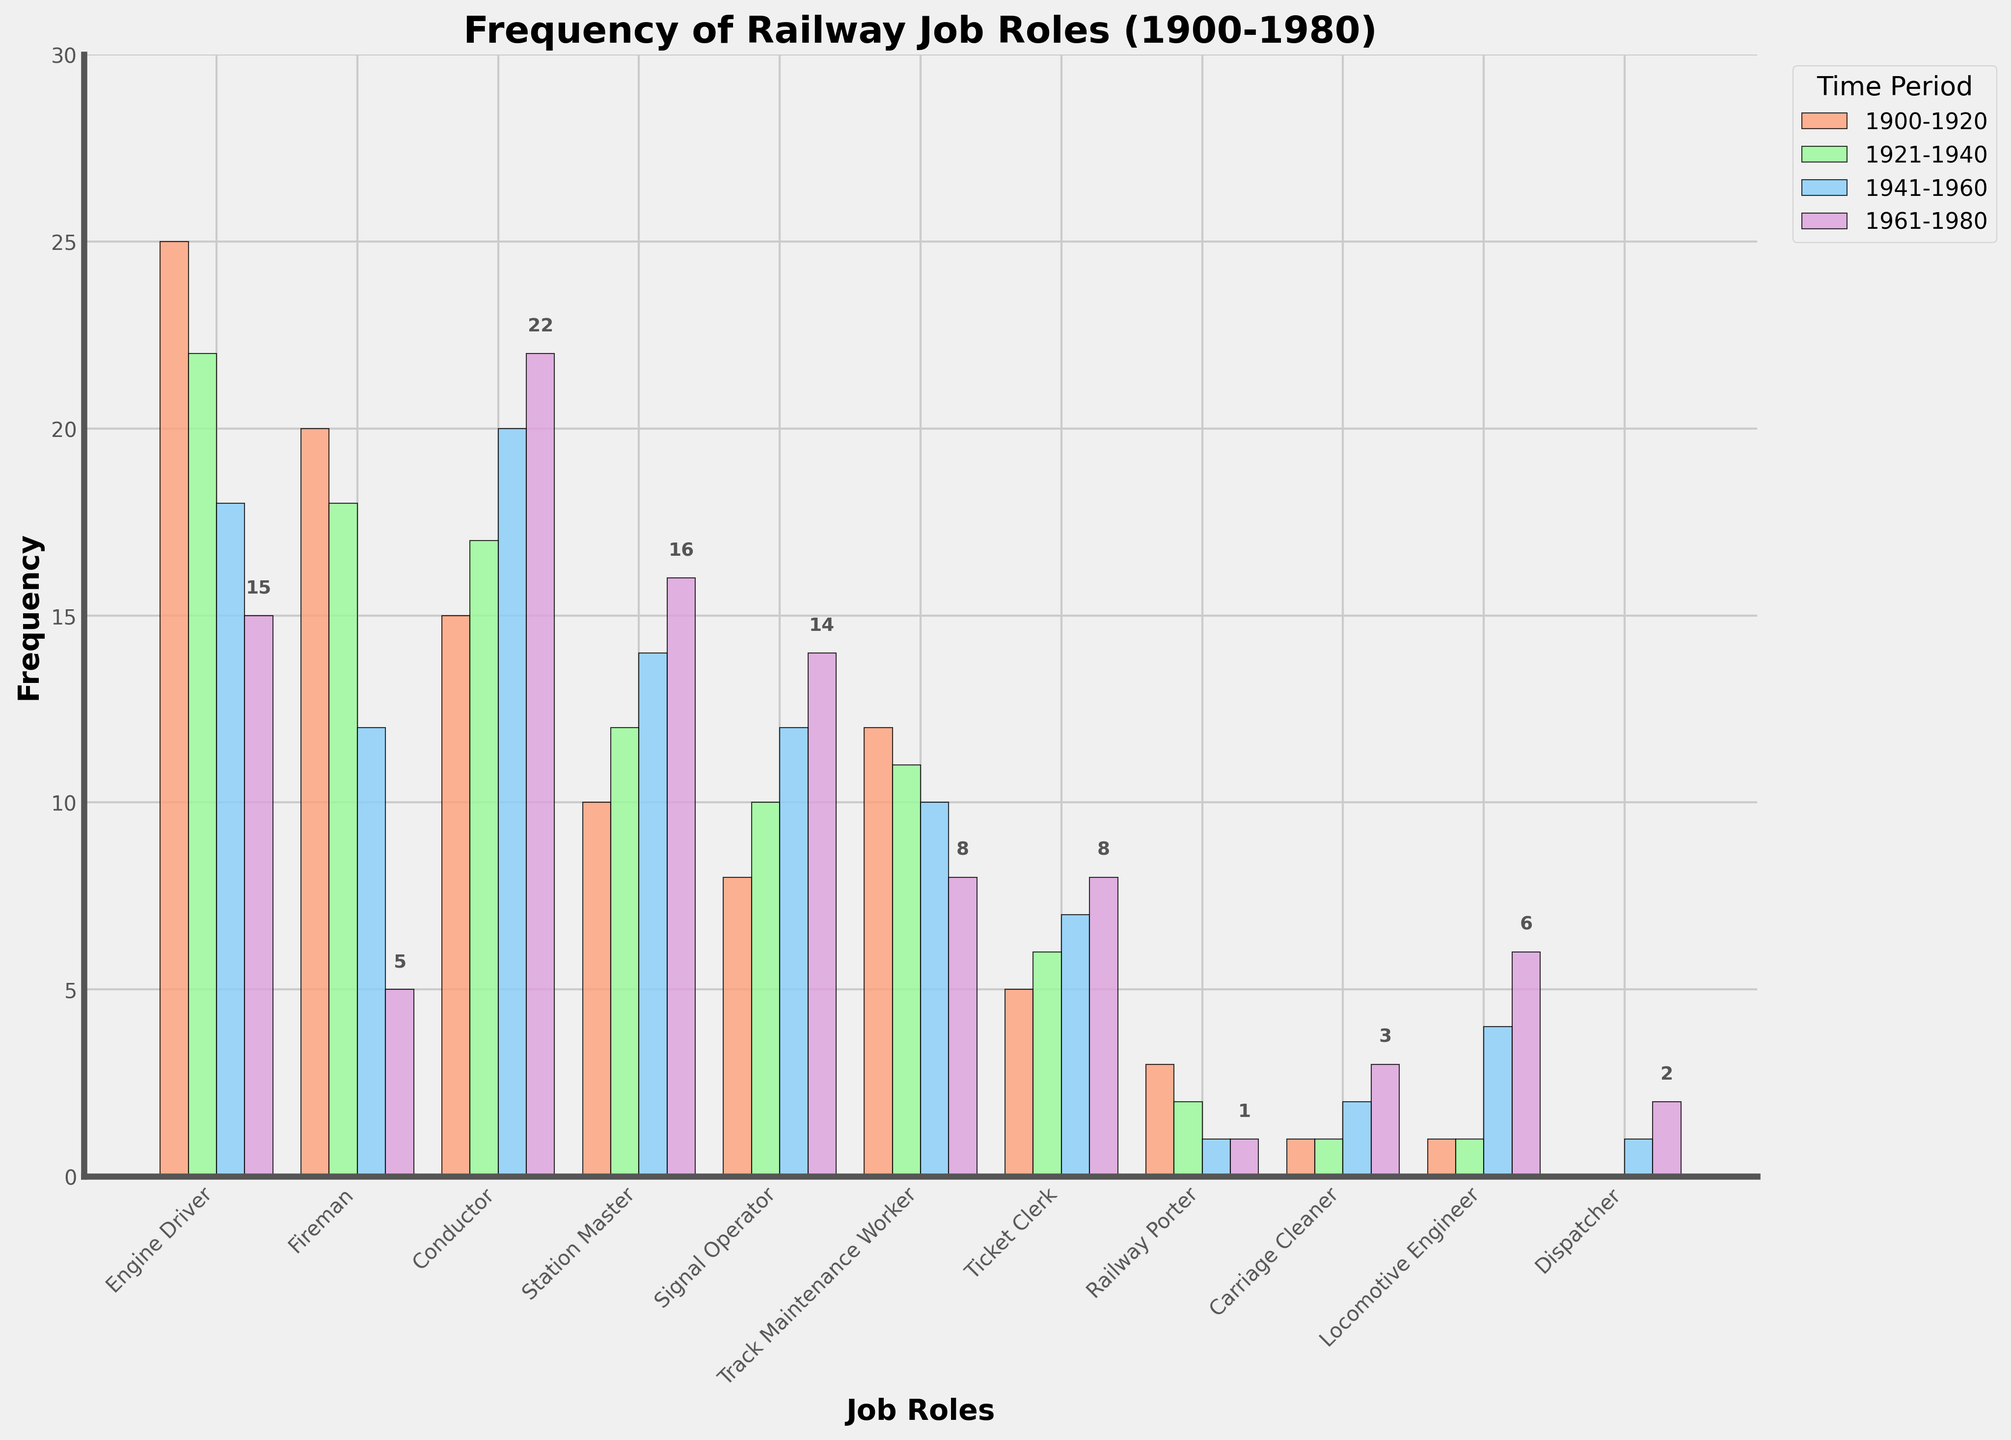What was the most common job role in the period 1900-1920? The job role with the highest frequency in the period 1900-1920 is identified by locating the tallest bar in the corresponding section of the bar chart. The 'Engine Driver' role has the tallest bar.
Answer: Engine Driver Which job role had the greatest increase in frequency from 1941-1960 to 1961-1980? To determine the job role with the greatest increase in frequency, compare the height of the bars between the periods 1941-1960 and 1961-1980 for each job role. The 'Conductor' increased from 20 to 22, which is the largest increase of 2.
Answer: Conductor How much did the frequency of the 'Fireman' role decrease from 1900-1920 to 1961-1980? Calculate the difference in frequency of the 'Fireman' role between 1900-1920 and 1961-1980 by subtracting the frequency in 1961-1980 from the frequency in 1900-1920 (20 - 5).
Answer: 15 Compare the frequency of the 'Station Master' and 'Signal Operator' roles in the period 1961-1980. Which one was more common? Compare the height of the bars for 'Station Master' (16) and 'Signal Operator' (14) in the period 1961-1980. 'Station Master' has a higher frequency.
Answer: Station Master What is the total frequency of the 'Ticket Clerk' role over all periods? Sum the frequencies of the 'Ticket Clerk' role across all periods: 5 (1900-1920) + 6 (1921-1940) + 7 (1941-1960) + 8 (1961-1980).
Answer: 26 In which period did the 'Locomotive Engineer' role experience its first increase in frequency? Identify the period when the 'Locomotive Engineer' first experienced a noticeable increase by analyzing the heights of the bars in sequence. The first increase is from 1941-1960 with a frequency of 4 compared to previous periods.
Answer: 1941-1960 How does the frequency of the 'Carriage Cleaner' role in 1961-1980 compare to its frequency in 1900-1920? Compare the height of the bars for 'Carriage Cleaner' in 1961-1980 (3) and 1900-1920 (1). 'Carriage Cleaner' is more common in 1961-1980.
Answer: More common in 1961-1980 Which job role shows a consistent increasing trend in frequency across all periods? Identify the job role whose frequency consistently increases from one period to the next. The 'Conductor' role shows a steady increase: 15, 17, 20, 22.
Answer: Conductor What is the average frequency of the 'Track Maintenance Worker' role over the periods? Calculate the average frequency by summing up the frequencies for 'Track Maintenance Worker' across all periods (12 + 11 + 10 + 8) and dividing by the number of periods, which is 4.
Answer: 10.25 Identify the period where the 'Dispatcher' role first appears, and give its frequency. Look at the periods to see when 'Dispatcher' first appears on the chart. It first appears in 1941-1960 with a frequency of 1.
Answer: 1941-1960, 1 